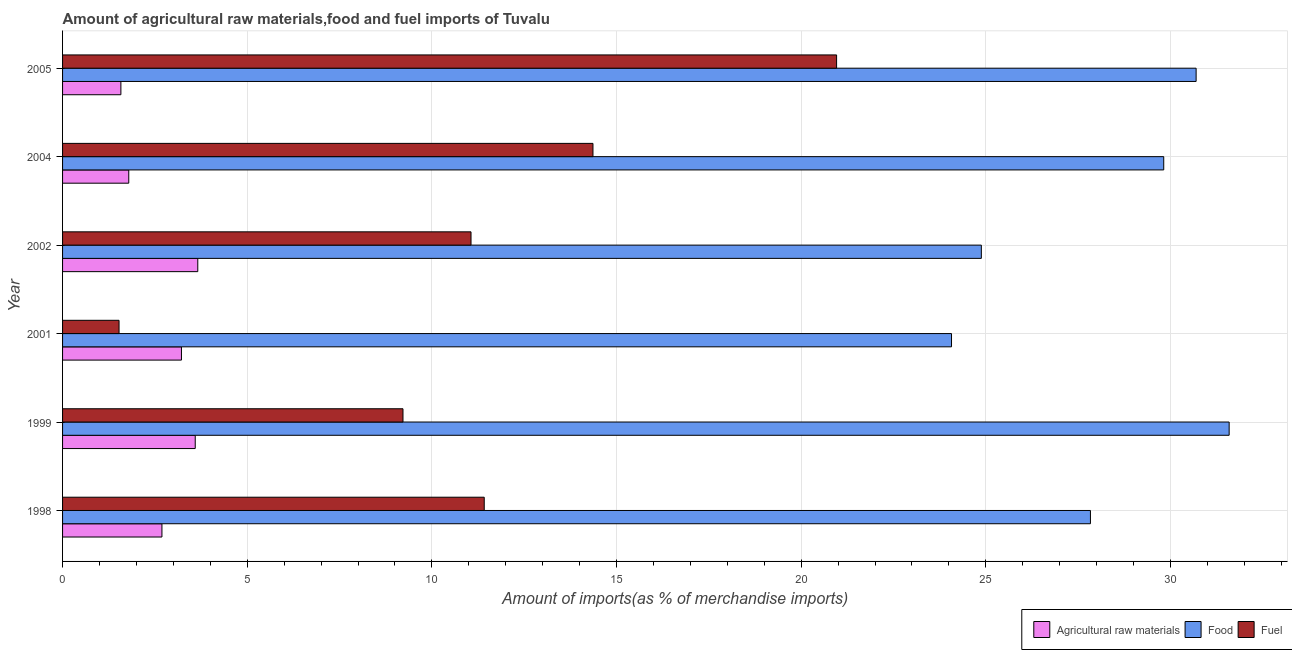How many groups of bars are there?
Your answer should be very brief. 6. Are the number of bars on each tick of the Y-axis equal?
Provide a succinct answer. Yes. How many bars are there on the 5th tick from the bottom?
Keep it short and to the point. 3. In how many cases, is the number of bars for a given year not equal to the number of legend labels?
Your answer should be compact. 0. What is the percentage of raw materials imports in 2004?
Your response must be concise. 1.79. Across all years, what is the maximum percentage of fuel imports?
Ensure brevity in your answer.  20.96. Across all years, what is the minimum percentage of fuel imports?
Your answer should be compact. 1.53. In which year was the percentage of fuel imports maximum?
Your answer should be compact. 2005. In which year was the percentage of fuel imports minimum?
Your answer should be compact. 2001. What is the total percentage of food imports in the graph?
Provide a short and direct response. 168.89. What is the difference between the percentage of fuel imports in 2001 and that in 2005?
Give a very brief answer. -19.43. What is the difference between the percentage of fuel imports in 1999 and the percentage of food imports in 2004?
Your answer should be very brief. -20.6. What is the average percentage of fuel imports per year?
Your response must be concise. 11.43. In the year 1998, what is the difference between the percentage of raw materials imports and percentage of fuel imports?
Your answer should be compact. -8.73. In how many years, is the percentage of food imports greater than 32 %?
Ensure brevity in your answer.  0. What is the ratio of the percentage of raw materials imports in 2002 to that in 2005?
Ensure brevity in your answer.  2.32. Is the difference between the percentage of food imports in 2001 and 2004 greater than the difference between the percentage of raw materials imports in 2001 and 2004?
Keep it short and to the point. No. What is the difference between the highest and the second highest percentage of food imports?
Provide a short and direct response. 0.9. What is the difference between the highest and the lowest percentage of raw materials imports?
Offer a terse response. 2.08. In how many years, is the percentage of raw materials imports greater than the average percentage of raw materials imports taken over all years?
Offer a very short reply. 3. What does the 2nd bar from the top in 2002 represents?
Your answer should be compact. Food. What does the 3rd bar from the bottom in 2005 represents?
Your answer should be very brief. Fuel. Is it the case that in every year, the sum of the percentage of raw materials imports and percentage of food imports is greater than the percentage of fuel imports?
Give a very brief answer. Yes. How many years are there in the graph?
Keep it short and to the point. 6. Does the graph contain any zero values?
Your answer should be compact. No. How are the legend labels stacked?
Your answer should be compact. Horizontal. What is the title of the graph?
Your response must be concise. Amount of agricultural raw materials,food and fuel imports of Tuvalu. Does "Gaseous fuel" appear as one of the legend labels in the graph?
Your answer should be compact. No. What is the label or title of the X-axis?
Your answer should be very brief. Amount of imports(as % of merchandise imports). What is the label or title of the Y-axis?
Ensure brevity in your answer.  Year. What is the Amount of imports(as % of merchandise imports) in Agricultural raw materials in 1998?
Your response must be concise. 2.69. What is the Amount of imports(as % of merchandise imports) of Food in 1998?
Keep it short and to the point. 27.83. What is the Amount of imports(as % of merchandise imports) in Fuel in 1998?
Your answer should be compact. 11.42. What is the Amount of imports(as % of merchandise imports) of Agricultural raw materials in 1999?
Your answer should be very brief. 3.59. What is the Amount of imports(as % of merchandise imports) in Food in 1999?
Provide a succinct answer. 31.59. What is the Amount of imports(as % of merchandise imports) in Fuel in 1999?
Keep it short and to the point. 9.22. What is the Amount of imports(as % of merchandise imports) in Agricultural raw materials in 2001?
Your answer should be compact. 3.22. What is the Amount of imports(as % of merchandise imports) of Food in 2001?
Your response must be concise. 24.07. What is the Amount of imports(as % of merchandise imports) in Fuel in 2001?
Make the answer very short. 1.53. What is the Amount of imports(as % of merchandise imports) of Agricultural raw materials in 2002?
Make the answer very short. 3.66. What is the Amount of imports(as % of merchandise imports) of Food in 2002?
Your answer should be very brief. 24.88. What is the Amount of imports(as % of merchandise imports) in Fuel in 2002?
Your answer should be very brief. 11.06. What is the Amount of imports(as % of merchandise imports) of Agricultural raw materials in 2004?
Your answer should be very brief. 1.79. What is the Amount of imports(as % of merchandise imports) in Food in 2004?
Your answer should be very brief. 29.82. What is the Amount of imports(as % of merchandise imports) in Fuel in 2004?
Provide a short and direct response. 14.36. What is the Amount of imports(as % of merchandise imports) in Agricultural raw materials in 2005?
Give a very brief answer. 1.58. What is the Amount of imports(as % of merchandise imports) in Food in 2005?
Make the answer very short. 30.7. What is the Amount of imports(as % of merchandise imports) in Fuel in 2005?
Offer a terse response. 20.96. Across all years, what is the maximum Amount of imports(as % of merchandise imports) in Agricultural raw materials?
Your answer should be very brief. 3.66. Across all years, what is the maximum Amount of imports(as % of merchandise imports) in Food?
Provide a short and direct response. 31.59. Across all years, what is the maximum Amount of imports(as % of merchandise imports) of Fuel?
Keep it short and to the point. 20.96. Across all years, what is the minimum Amount of imports(as % of merchandise imports) of Agricultural raw materials?
Offer a terse response. 1.58. Across all years, what is the minimum Amount of imports(as % of merchandise imports) of Food?
Offer a very short reply. 24.07. Across all years, what is the minimum Amount of imports(as % of merchandise imports) of Fuel?
Offer a very short reply. 1.53. What is the total Amount of imports(as % of merchandise imports) in Agricultural raw materials in the graph?
Provide a short and direct response. 16.54. What is the total Amount of imports(as % of merchandise imports) in Food in the graph?
Ensure brevity in your answer.  168.89. What is the total Amount of imports(as % of merchandise imports) in Fuel in the graph?
Give a very brief answer. 68.55. What is the difference between the Amount of imports(as % of merchandise imports) in Agricultural raw materials in 1998 and that in 1999?
Ensure brevity in your answer.  -0.9. What is the difference between the Amount of imports(as % of merchandise imports) of Food in 1998 and that in 1999?
Provide a succinct answer. -3.76. What is the difference between the Amount of imports(as % of merchandise imports) of Fuel in 1998 and that in 1999?
Provide a succinct answer. 2.2. What is the difference between the Amount of imports(as % of merchandise imports) in Agricultural raw materials in 1998 and that in 2001?
Provide a short and direct response. -0.53. What is the difference between the Amount of imports(as % of merchandise imports) in Food in 1998 and that in 2001?
Your answer should be compact. 3.76. What is the difference between the Amount of imports(as % of merchandise imports) in Fuel in 1998 and that in 2001?
Keep it short and to the point. 9.89. What is the difference between the Amount of imports(as % of merchandise imports) in Agricultural raw materials in 1998 and that in 2002?
Make the answer very short. -0.97. What is the difference between the Amount of imports(as % of merchandise imports) of Food in 1998 and that in 2002?
Provide a short and direct response. 2.95. What is the difference between the Amount of imports(as % of merchandise imports) in Fuel in 1998 and that in 2002?
Your response must be concise. 0.36. What is the difference between the Amount of imports(as % of merchandise imports) of Agricultural raw materials in 1998 and that in 2004?
Make the answer very short. 0.9. What is the difference between the Amount of imports(as % of merchandise imports) of Food in 1998 and that in 2004?
Keep it short and to the point. -1.98. What is the difference between the Amount of imports(as % of merchandise imports) of Fuel in 1998 and that in 2004?
Provide a short and direct response. -2.94. What is the difference between the Amount of imports(as % of merchandise imports) in Agricultural raw materials in 1998 and that in 2005?
Provide a succinct answer. 1.11. What is the difference between the Amount of imports(as % of merchandise imports) in Food in 1998 and that in 2005?
Keep it short and to the point. -2.86. What is the difference between the Amount of imports(as % of merchandise imports) in Fuel in 1998 and that in 2005?
Your response must be concise. -9.54. What is the difference between the Amount of imports(as % of merchandise imports) of Agricultural raw materials in 1999 and that in 2001?
Offer a very short reply. 0.37. What is the difference between the Amount of imports(as % of merchandise imports) of Food in 1999 and that in 2001?
Ensure brevity in your answer.  7.52. What is the difference between the Amount of imports(as % of merchandise imports) of Fuel in 1999 and that in 2001?
Your response must be concise. 7.69. What is the difference between the Amount of imports(as % of merchandise imports) of Agricultural raw materials in 1999 and that in 2002?
Your response must be concise. -0.07. What is the difference between the Amount of imports(as % of merchandise imports) in Food in 1999 and that in 2002?
Your response must be concise. 6.71. What is the difference between the Amount of imports(as % of merchandise imports) in Fuel in 1999 and that in 2002?
Keep it short and to the point. -1.84. What is the difference between the Amount of imports(as % of merchandise imports) of Food in 1999 and that in 2004?
Your answer should be compact. 1.77. What is the difference between the Amount of imports(as % of merchandise imports) of Fuel in 1999 and that in 2004?
Ensure brevity in your answer.  -5.14. What is the difference between the Amount of imports(as % of merchandise imports) of Agricultural raw materials in 1999 and that in 2005?
Your response must be concise. 2.01. What is the difference between the Amount of imports(as % of merchandise imports) of Food in 1999 and that in 2005?
Your answer should be very brief. 0.89. What is the difference between the Amount of imports(as % of merchandise imports) in Fuel in 1999 and that in 2005?
Offer a terse response. -11.74. What is the difference between the Amount of imports(as % of merchandise imports) in Agricultural raw materials in 2001 and that in 2002?
Give a very brief answer. -0.44. What is the difference between the Amount of imports(as % of merchandise imports) in Food in 2001 and that in 2002?
Your response must be concise. -0.81. What is the difference between the Amount of imports(as % of merchandise imports) of Fuel in 2001 and that in 2002?
Your answer should be compact. -9.53. What is the difference between the Amount of imports(as % of merchandise imports) of Agricultural raw materials in 2001 and that in 2004?
Make the answer very short. 1.43. What is the difference between the Amount of imports(as % of merchandise imports) in Food in 2001 and that in 2004?
Your answer should be compact. -5.75. What is the difference between the Amount of imports(as % of merchandise imports) in Fuel in 2001 and that in 2004?
Give a very brief answer. -12.83. What is the difference between the Amount of imports(as % of merchandise imports) of Agricultural raw materials in 2001 and that in 2005?
Your answer should be compact. 1.64. What is the difference between the Amount of imports(as % of merchandise imports) in Food in 2001 and that in 2005?
Your answer should be very brief. -6.62. What is the difference between the Amount of imports(as % of merchandise imports) of Fuel in 2001 and that in 2005?
Your answer should be compact. -19.43. What is the difference between the Amount of imports(as % of merchandise imports) in Agricultural raw materials in 2002 and that in 2004?
Your response must be concise. 1.87. What is the difference between the Amount of imports(as % of merchandise imports) of Food in 2002 and that in 2004?
Ensure brevity in your answer.  -4.94. What is the difference between the Amount of imports(as % of merchandise imports) of Fuel in 2002 and that in 2004?
Make the answer very short. -3.3. What is the difference between the Amount of imports(as % of merchandise imports) in Agricultural raw materials in 2002 and that in 2005?
Your answer should be compact. 2.08. What is the difference between the Amount of imports(as % of merchandise imports) in Food in 2002 and that in 2005?
Provide a succinct answer. -5.82. What is the difference between the Amount of imports(as % of merchandise imports) of Fuel in 2002 and that in 2005?
Your response must be concise. -9.9. What is the difference between the Amount of imports(as % of merchandise imports) of Agricultural raw materials in 2004 and that in 2005?
Keep it short and to the point. 0.21. What is the difference between the Amount of imports(as % of merchandise imports) of Food in 2004 and that in 2005?
Your response must be concise. -0.88. What is the difference between the Amount of imports(as % of merchandise imports) in Fuel in 2004 and that in 2005?
Your answer should be very brief. -6.6. What is the difference between the Amount of imports(as % of merchandise imports) in Agricultural raw materials in 1998 and the Amount of imports(as % of merchandise imports) in Food in 1999?
Give a very brief answer. -28.9. What is the difference between the Amount of imports(as % of merchandise imports) in Agricultural raw materials in 1998 and the Amount of imports(as % of merchandise imports) in Fuel in 1999?
Your response must be concise. -6.53. What is the difference between the Amount of imports(as % of merchandise imports) in Food in 1998 and the Amount of imports(as % of merchandise imports) in Fuel in 1999?
Ensure brevity in your answer.  18.62. What is the difference between the Amount of imports(as % of merchandise imports) of Agricultural raw materials in 1998 and the Amount of imports(as % of merchandise imports) of Food in 2001?
Offer a terse response. -21.38. What is the difference between the Amount of imports(as % of merchandise imports) of Agricultural raw materials in 1998 and the Amount of imports(as % of merchandise imports) of Fuel in 2001?
Your response must be concise. 1.16. What is the difference between the Amount of imports(as % of merchandise imports) of Food in 1998 and the Amount of imports(as % of merchandise imports) of Fuel in 2001?
Provide a short and direct response. 26.3. What is the difference between the Amount of imports(as % of merchandise imports) in Agricultural raw materials in 1998 and the Amount of imports(as % of merchandise imports) in Food in 2002?
Make the answer very short. -22.19. What is the difference between the Amount of imports(as % of merchandise imports) in Agricultural raw materials in 1998 and the Amount of imports(as % of merchandise imports) in Fuel in 2002?
Offer a terse response. -8.37. What is the difference between the Amount of imports(as % of merchandise imports) of Food in 1998 and the Amount of imports(as % of merchandise imports) of Fuel in 2002?
Ensure brevity in your answer.  16.77. What is the difference between the Amount of imports(as % of merchandise imports) in Agricultural raw materials in 1998 and the Amount of imports(as % of merchandise imports) in Food in 2004?
Offer a terse response. -27.13. What is the difference between the Amount of imports(as % of merchandise imports) in Agricultural raw materials in 1998 and the Amount of imports(as % of merchandise imports) in Fuel in 2004?
Provide a short and direct response. -11.67. What is the difference between the Amount of imports(as % of merchandise imports) of Food in 1998 and the Amount of imports(as % of merchandise imports) of Fuel in 2004?
Provide a succinct answer. 13.47. What is the difference between the Amount of imports(as % of merchandise imports) in Agricultural raw materials in 1998 and the Amount of imports(as % of merchandise imports) in Food in 2005?
Give a very brief answer. -28. What is the difference between the Amount of imports(as % of merchandise imports) of Agricultural raw materials in 1998 and the Amount of imports(as % of merchandise imports) of Fuel in 2005?
Ensure brevity in your answer.  -18.27. What is the difference between the Amount of imports(as % of merchandise imports) in Food in 1998 and the Amount of imports(as % of merchandise imports) in Fuel in 2005?
Ensure brevity in your answer.  6.87. What is the difference between the Amount of imports(as % of merchandise imports) in Agricultural raw materials in 1999 and the Amount of imports(as % of merchandise imports) in Food in 2001?
Your response must be concise. -20.48. What is the difference between the Amount of imports(as % of merchandise imports) in Agricultural raw materials in 1999 and the Amount of imports(as % of merchandise imports) in Fuel in 2001?
Offer a terse response. 2.06. What is the difference between the Amount of imports(as % of merchandise imports) of Food in 1999 and the Amount of imports(as % of merchandise imports) of Fuel in 2001?
Your answer should be very brief. 30.06. What is the difference between the Amount of imports(as % of merchandise imports) in Agricultural raw materials in 1999 and the Amount of imports(as % of merchandise imports) in Food in 2002?
Your answer should be compact. -21.29. What is the difference between the Amount of imports(as % of merchandise imports) of Agricultural raw materials in 1999 and the Amount of imports(as % of merchandise imports) of Fuel in 2002?
Ensure brevity in your answer.  -7.47. What is the difference between the Amount of imports(as % of merchandise imports) in Food in 1999 and the Amount of imports(as % of merchandise imports) in Fuel in 2002?
Give a very brief answer. 20.53. What is the difference between the Amount of imports(as % of merchandise imports) in Agricultural raw materials in 1999 and the Amount of imports(as % of merchandise imports) in Food in 2004?
Provide a short and direct response. -26.23. What is the difference between the Amount of imports(as % of merchandise imports) of Agricultural raw materials in 1999 and the Amount of imports(as % of merchandise imports) of Fuel in 2004?
Your response must be concise. -10.77. What is the difference between the Amount of imports(as % of merchandise imports) of Food in 1999 and the Amount of imports(as % of merchandise imports) of Fuel in 2004?
Provide a succinct answer. 17.23. What is the difference between the Amount of imports(as % of merchandise imports) of Agricultural raw materials in 1999 and the Amount of imports(as % of merchandise imports) of Food in 2005?
Make the answer very short. -27.1. What is the difference between the Amount of imports(as % of merchandise imports) in Agricultural raw materials in 1999 and the Amount of imports(as % of merchandise imports) in Fuel in 2005?
Your response must be concise. -17.37. What is the difference between the Amount of imports(as % of merchandise imports) of Food in 1999 and the Amount of imports(as % of merchandise imports) of Fuel in 2005?
Provide a short and direct response. 10.63. What is the difference between the Amount of imports(as % of merchandise imports) in Agricultural raw materials in 2001 and the Amount of imports(as % of merchandise imports) in Food in 2002?
Keep it short and to the point. -21.66. What is the difference between the Amount of imports(as % of merchandise imports) in Agricultural raw materials in 2001 and the Amount of imports(as % of merchandise imports) in Fuel in 2002?
Your answer should be very brief. -7.84. What is the difference between the Amount of imports(as % of merchandise imports) of Food in 2001 and the Amount of imports(as % of merchandise imports) of Fuel in 2002?
Provide a succinct answer. 13.01. What is the difference between the Amount of imports(as % of merchandise imports) of Agricultural raw materials in 2001 and the Amount of imports(as % of merchandise imports) of Food in 2004?
Your answer should be compact. -26.6. What is the difference between the Amount of imports(as % of merchandise imports) of Agricultural raw materials in 2001 and the Amount of imports(as % of merchandise imports) of Fuel in 2004?
Provide a short and direct response. -11.14. What is the difference between the Amount of imports(as % of merchandise imports) of Food in 2001 and the Amount of imports(as % of merchandise imports) of Fuel in 2004?
Offer a terse response. 9.71. What is the difference between the Amount of imports(as % of merchandise imports) of Agricultural raw materials in 2001 and the Amount of imports(as % of merchandise imports) of Food in 2005?
Offer a terse response. -27.48. What is the difference between the Amount of imports(as % of merchandise imports) in Agricultural raw materials in 2001 and the Amount of imports(as % of merchandise imports) in Fuel in 2005?
Ensure brevity in your answer.  -17.74. What is the difference between the Amount of imports(as % of merchandise imports) in Food in 2001 and the Amount of imports(as % of merchandise imports) in Fuel in 2005?
Your answer should be very brief. 3.11. What is the difference between the Amount of imports(as % of merchandise imports) of Agricultural raw materials in 2002 and the Amount of imports(as % of merchandise imports) of Food in 2004?
Provide a short and direct response. -26.16. What is the difference between the Amount of imports(as % of merchandise imports) in Agricultural raw materials in 2002 and the Amount of imports(as % of merchandise imports) in Fuel in 2004?
Your answer should be very brief. -10.7. What is the difference between the Amount of imports(as % of merchandise imports) of Food in 2002 and the Amount of imports(as % of merchandise imports) of Fuel in 2004?
Provide a succinct answer. 10.52. What is the difference between the Amount of imports(as % of merchandise imports) in Agricultural raw materials in 2002 and the Amount of imports(as % of merchandise imports) in Food in 2005?
Keep it short and to the point. -27.03. What is the difference between the Amount of imports(as % of merchandise imports) of Agricultural raw materials in 2002 and the Amount of imports(as % of merchandise imports) of Fuel in 2005?
Offer a terse response. -17.3. What is the difference between the Amount of imports(as % of merchandise imports) of Food in 2002 and the Amount of imports(as % of merchandise imports) of Fuel in 2005?
Your answer should be compact. 3.92. What is the difference between the Amount of imports(as % of merchandise imports) of Agricultural raw materials in 2004 and the Amount of imports(as % of merchandise imports) of Food in 2005?
Your response must be concise. -28.9. What is the difference between the Amount of imports(as % of merchandise imports) in Agricultural raw materials in 2004 and the Amount of imports(as % of merchandise imports) in Fuel in 2005?
Your response must be concise. -19.17. What is the difference between the Amount of imports(as % of merchandise imports) in Food in 2004 and the Amount of imports(as % of merchandise imports) in Fuel in 2005?
Give a very brief answer. 8.86. What is the average Amount of imports(as % of merchandise imports) of Agricultural raw materials per year?
Your response must be concise. 2.76. What is the average Amount of imports(as % of merchandise imports) of Food per year?
Provide a succinct answer. 28.15. What is the average Amount of imports(as % of merchandise imports) of Fuel per year?
Offer a very short reply. 11.42. In the year 1998, what is the difference between the Amount of imports(as % of merchandise imports) in Agricultural raw materials and Amount of imports(as % of merchandise imports) in Food?
Offer a very short reply. -25.14. In the year 1998, what is the difference between the Amount of imports(as % of merchandise imports) of Agricultural raw materials and Amount of imports(as % of merchandise imports) of Fuel?
Your response must be concise. -8.73. In the year 1998, what is the difference between the Amount of imports(as % of merchandise imports) in Food and Amount of imports(as % of merchandise imports) in Fuel?
Your answer should be very brief. 16.42. In the year 1999, what is the difference between the Amount of imports(as % of merchandise imports) of Agricultural raw materials and Amount of imports(as % of merchandise imports) of Food?
Keep it short and to the point. -28. In the year 1999, what is the difference between the Amount of imports(as % of merchandise imports) of Agricultural raw materials and Amount of imports(as % of merchandise imports) of Fuel?
Keep it short and to the point. -5.63. In the year 1999, what is the difference between the Amount of imports(as % of merchandise imports) of Food and Amount of imports(as % of merchandise imports) of Fuel?
Keep it short and to the point. 22.37. In the year 2001, what is the difference between the Amount of imports(as % of merchandise imports) of Agricultural raw materials and Amount of imports(as % of merchandise imports) of Food?
Your response must be concise. -20.85. In the year 2001, what is the difference between the Amount of imports(as % of merchandise imports) of Agricultural raw materials and Amount of imports(as % of merchandise imports) of Fuel?
Your answer should be compact. 1.69. In the year 2001, what is the difference between the Amount of imports(as % of merchandise imports) of Food and Amount of imports(as % of merchandise imports) of Fuel?
Provide a short and direct response. 22.54. In the year 2002, what is the difference between the Amount of imports(as % of merchandise imports) of Agricultural raw materials and Amount of imports(as % of merchandise imports) of Food?
Offer a terse response. -21.22. In the year 2002, what is the difference between the Amount of imports(as % of merchandise imports) in Agricultural raw materials and Amount of imports(as % of merchandise imports) in Fuel?
Give a very brief answer. -7.4. In the year 2002, what is the difference between the Amount of imports(as % of merchandise imports) in Food and Amount of imports(as % of merchandise imports) in Fuel?
Provide a short and direct response. 13.82. In the year 2004, what is the difference between the Amount of imports(as % of merchandise imports) in Agricultural raw materials and Amount of imports(as % of merchandise imports) in Food?
Your response must be concise. -28.03. In the year 2004, what is the difference between the Amount of imports(as % of merchandise imports) of Agricultural raw materials and Amount of imports(as % of merchandise imports) of Fuel?
Your response must be concise. -12.57. In the year 2004, what is the difference between the Amount of imports(as % of merchandise imports) of Food and Amount of imports(as % of merchandise imports) of Fuel?
Ensure brevity in your answer.  15.46. In the year 2005, what is the difference between the Amount of imports(as % of merchandise imports) in Agricultural raw materials and Amount of imports(as % of merchandise imports) in Food?
Make the answer very short. -29.12. In the year 2005, what is the difference between the Amount of imports(as % of merchandise imports) of Agricultural raw materials and Amount of imports(as % of merchandise imports) of Fuel?
Your answer should be very brief. -19.38. In the year 2005, what is the difference between the Amount of imports(as % of merchandise imports) in Food and Amount of imports(as % of merchandise imports) in Fuel?
Keep it short and to the point. 9.74. What is the ratio of the Amount of imports(as % of merchandise imports) of Agricultural raw materials in 1998 to that in 1999?
Keep it short and to the point. 0.75. What is the ratio of the Amount of imports(as % of merchandise imports) in Food in 1998 to that in 1999?
Your answer should be very brief. 0.88. What is the ratio of the Amount of imports(as % of merchandise imports) in Fuel in 1998 to that in 1999?
Provide a succinct answer. 1.24. What is the ratio of the Amount of imports(as % of merchandise imports) in Agricultural raw materials in 1998 to that in 2001?
Give a very brief answer. 0.84. What is the ratio of the Amount of imports(as % of merchandise imports) in Food in 1998 to that in 2001?
Keep it short and to the point. 1.16. What is the ratio of the Amount of imports(as % of merchandise imports) of Fuel in 1998 to that in 2001?
Keep it short and to the point. 7.46. What is the ratio of the Amount of imports(as % of merchandise imports) in Agricultural raw materials in 1998 to that in 2002?
Your response must be concise. 0.73. What is the ratio of the Amount of imports(as % of merchandise imports) of Food in 1998 to that in 2002?
Make the answer very short. 1.12. What is the ratio of the Amount of imports(as % of merchandise imports) of Fuel in 1998 to that in 2002?
Offer a terse response. 1.03. What is the ratio of the Amount of imports(as % of merchandise imports) in Agricultural raw materials in 1998 to that in 2004?
Keep it short and to the point. 1.5. What is the ratio of the Amount of imports(as % of merchandise imports) of Food in 1998 to that in 2004?
Give a very brief answer. 0.93. What is the ratio of the Amount of imports(as % of merchandise imports) of Fuel in 1998 to that in 2004?
Your response must be concise. 0.8. What is the ratio of the Amount of imports(as % of merchandise imports) in Agricultural raw materials in 1998 to that in 2005?
Offer a very short reply. 1.7. What is the ratio of the Amount of imports(as % of merchandise imports) in Food in 1998 to that in 2005?
Your answer should be compact. 0.91. What is the ratio of the Amount of imports(as % of merchandise imports) of Fuel in 1998 to that in 2005?
Your answer should be very brief. 0.54. What is the ratio of the Amount of imports(as % of merchandise imports) in Agricultural raw materials in 1999 to that in 2001?
Your response must be concise. 1.12. What is the ratio of the Amount of imports(as % of merchandise imports) of Food in 1999 to that in 2001?
Provide a short and direct response. 1.31. What is the ratio of the Amount of imports(as % of merchandise imports) of Fuel in 1999 to that in 2001?
Provide a succinct answer. 6.03. What is the ratio of the Amount of imports(as % of merchandise imports) in Agricultural raw materials in 1999 to that in 2002?
Your answer should be compact. 0.98. What is the ratio of the Amount of imports(as % of merchandise imports) in Food in 1999 to that in 2002?
Provide a short and direct response. 1.27. What is the ratio of the Amount of imports(as % of merchandise imports) of Fuel in 1999 to that in 2002?
Offer a very short reply. 0.83. What is the ratio of the Amount of imports(as % of merchandise imports) of Agricultural raw materials in 1999 to that in 2004?
Your answer should be compact. 2. What is the ratio of the Amount of imports(as % of merchandise imports) in Food in 1999 to that in 2004?
Your response must be concise. 1.06. What is the ratio of the Amount of imports(as % of merchandise imports) in Fuel in 1999 to that in 2004?
Provide a succinct answer. 0.64. What is the ratio of the Amount of imports(as % of merchandise imports) of Agricultural raw materials in 1999 to that in 2005?
Make the answer very short. 2.27. What is the ratio of the Amount of imports(as % of merchandise imports) in Food in 1999 to that in 2005?
Your answer should be compact. 1.03. What is the ratio of the Amount of imports(as % of merchandise imports) in Fuel in 1999 to that in 2005?
Keep it short and to the point. 0.44. What is the ratio of the Amount of imports(as % of merchandise imports) in Agricultural raw materials in 2001 to that in 2002?
Offer a very short reply. 0.88. What is the ratio of the Amount of imports(as % of merchandise imports) of Food in 2001 to that in 2002?
Make the answer very short. 0.97. What is the ratio of the Amount of imports(as % of merchandise imports) of Fuel in 2001 to that in 2002?
Your answer should be very brief. 0.14. What is the ratio of the Amount of imports(as % of merchandise imports) of Agricultural raw materials in 2001 to that in 2004?
Your answer should be compact. 1.8. What is the ratio of the Amount of imports(as % of merchandise imports) of Food in 2001 to that in 2004?
Make the answer very short. 0.81. What is the ratio of the Amount of imports(as % of merchandise imports) of Fuel in 2001 to that in 2004?
Keep it short and to the point. 0.11. What is the ratio of the Amount of imports(as % of merchandise imports) of Agricultural raw materials in 2001 to that in 2005?
Ensure brevity in your answer.  2.04. What is the ratio of the Amount of imports(as % of merchandise imports) of Food in 2001 to that in 2005?
Offer a terse response. 0.78. What is the ratio of the Amount of imports(as % of merchandise imports) in Fuel in 2001 to that in 2005?
Your response must be concise. 0.07. What is the ratio of the Amount of imports(as % of merchandise imports) in Agricultural raw materials in 2002 to that in 2004?
Provide a short and direct response. 2.04. What is the ratio of the Amount of imports(as % of merchandise imports) in Food in 2002 to that in 2004?
Give a very brief answer. 0.83. What is the ratio of the Amount of imports(as % of merchandise imports) in Fuel in 2002 to that in 2004?
Make the answer very short. 0.77. What is the ratio of the Amount of imports(as % of merchandise imports) of Agricultural raw materials in 2002 to that in 2005?
Make the answer very short. 2.32. What is the ratio of the Amount of imports(as % of merchandise imports) of Food in 2002 to that in 2005?
Give a very brief answer. 0.81. What is the ratio of the Amount of imports(as % of merchandise imports) in Fuel in 2002 to that in 2005?
Provide a short and direct response. 0.53. What is the ratio of the Amount of imports(as % of merchandise imports) in Agricultural raw materials in 2004 to that in 2005?
Keep it short and to the point. 1.13. What is the ratio of the Amount of imports(as % of merchandise imports) of Food in 2004 to that in 2005?
Offer a very short reply. 0.97. What is the ratio of the Amount of imports(as % of merchandise imports) of Fuel in 2004 to that in 2005?
Your response must be concise. 0.69. What is the difference between the highest and the second highest Amount of imports(as % of merchandise imports) in Agricultural raw materials?
Provide a short and direct response. 0.07. What is the difference between the highest and the second highest Amount of imports(as % of merchandise imports) in Food?
Make the answer very short. 0.89. What is the difference between the highest and the second highest Amount of imports(as % of merchandise imports) of Fuel?
Make the answer very short. 6.6. What is the difference between the highest and the lowest Amount of imports(as % of merchandise imports) of Agricultural raw materials?
Offer a terse response. 2.08. What is the difference between the highest and the lowest Amount of imports(as % of merchandise imports) in Food?
Offer a terse response. 7.52. What is the difference between the highest and the lowest Amount of imports(as % of merchandise imports) in Fuel?
Make the answer very short. 19.43. 